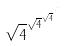<formula> <loc_0><loc_0><loc_500><loc_500>\sqrt { 4 } ^ { \sqrt { 4 } ^ { \sqrt { 4 } ^ { \cdot ^ { \cdot ^ { \cdot } } } } }</formula> 